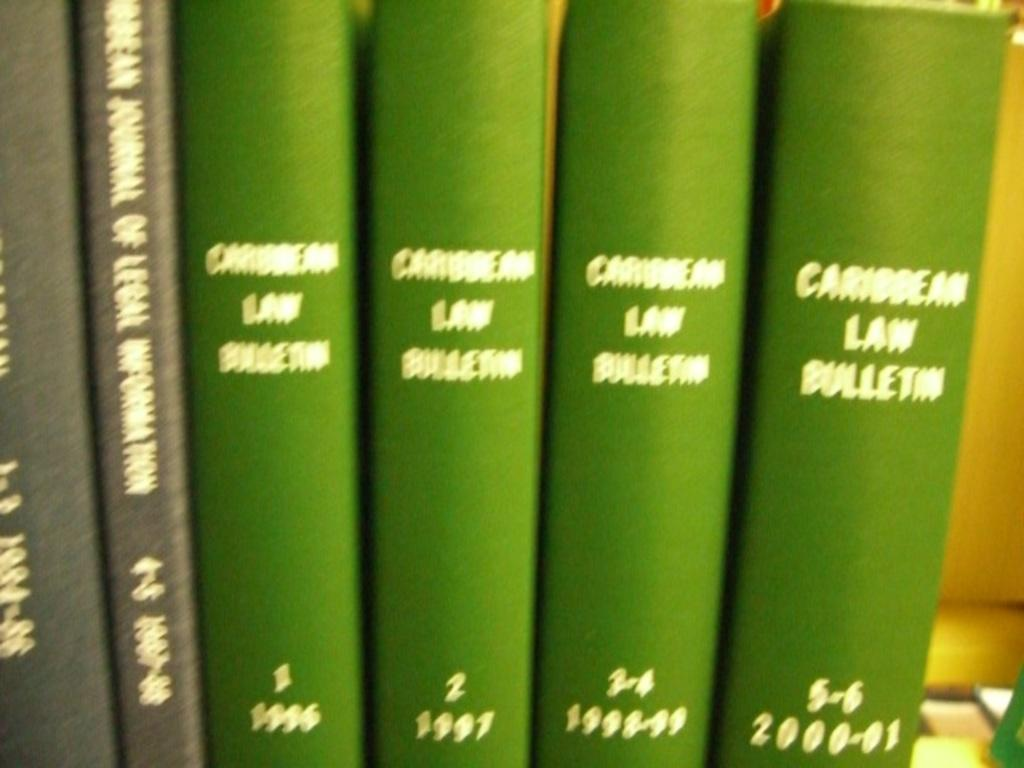What objects are present in the image? There are books in the image. Can you describe the appearance of the books? The books are green and black in color. What color is the background of the image? The background of the image is yellow. How does the sponge show respect to the books in the image? There is no sponge present in the image, so it cannot show respect to the books. 